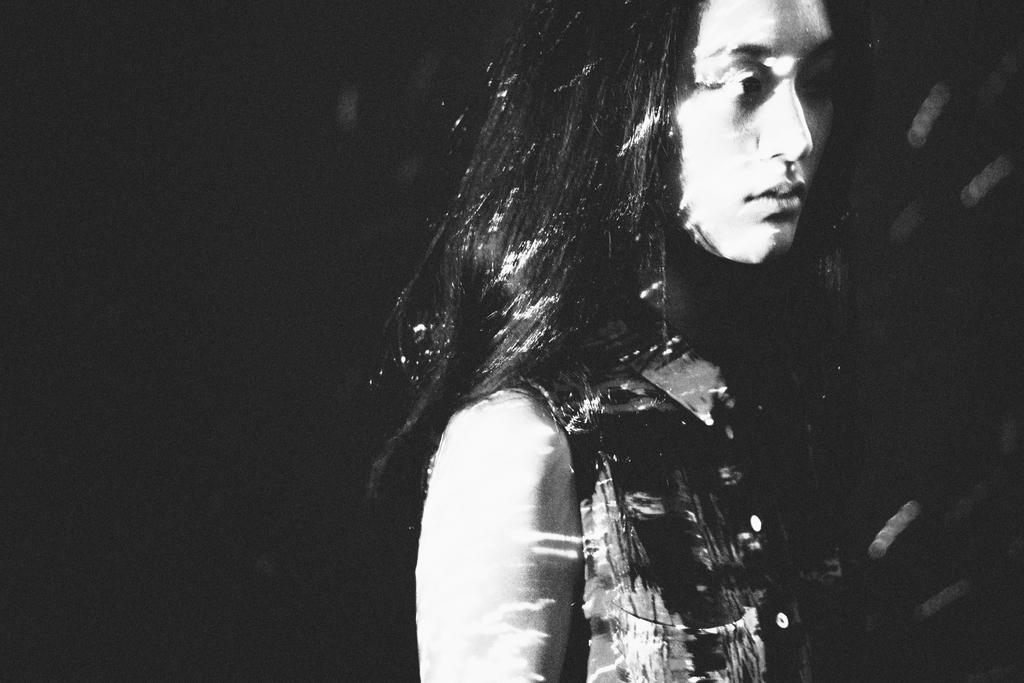What is the color scheme of the image? The image is black and white. Who is the main subject in the image? There is a girl in the image. What can be observed about the background of the image? The background of the image is dark. What is the girl's opinion on the ongoing discussion in the image? There is no discussion present in the image, so it is not possible to determine the girl's opinion on any discussion. 